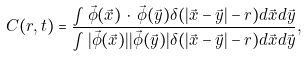Convert formula to latex. <formula><loc_0><loc_0><loc_500><loc_500>C ( r , t ) = \frac { \int { \vec { \phi } } ( \vec { x } ) \, \cdot \, { \vec { \phi } } ( \vec { y } ) \delta ( | \vec { x } - \vec { y } | - r ) d \vec { x } d \vec { y } } { \int | { \vec { \phi } } ( \vec { x } ) | | { \vec { \phi } } ( \vec { y } ) | \delta ( | \vec { x } - \vec { y } | - r ) d \vec { x } d \vec { y } } ,</formula> 